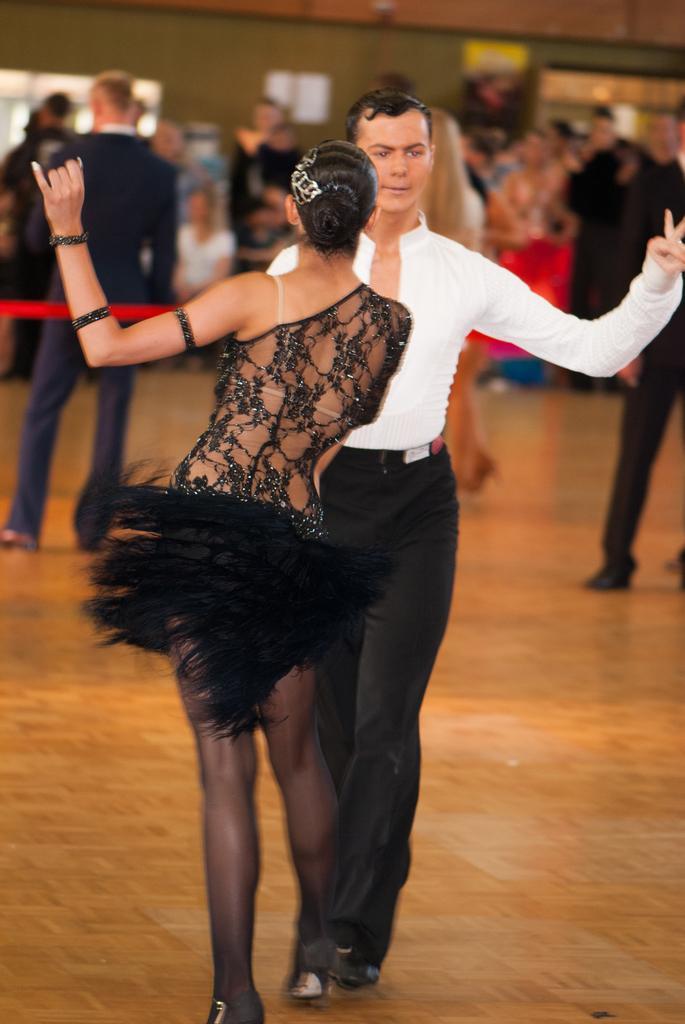Please provide a concise description of this image. In the picture I can see three people are standing on the wooden floor. In the background I can see a wall and some other objects. The background of the image is blurred. 